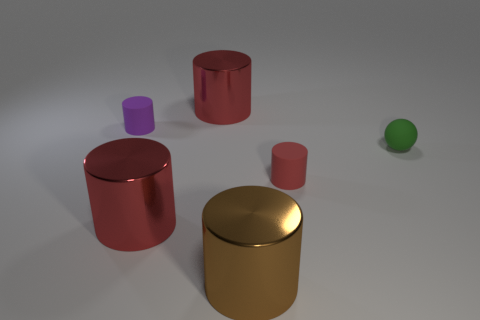Subtract all cyan balls. How many red cylinders are left? 3 Subtract all large brown shiny cylinders. How many cylinders are left? 4 Subtract all purple cylinders. How many cylinders are left? 4 Subtract all yellow cylinders. Subtract all red balls. How many cylinders are left? 5 Add 4 cylinders. How many objects exist? 10 Subtract all spheres. How many objects are left? 5 Subtract all green spheres. Subtract all large blue metal balls. How many objects are left? 5 Add 6 purple matte cylinders. How many purple matte cylinders are left? 7 Add 5 green metallic things. How many green metallic things exist? 5 Subtract 0 blue cylinders. How many objects are left? 6 